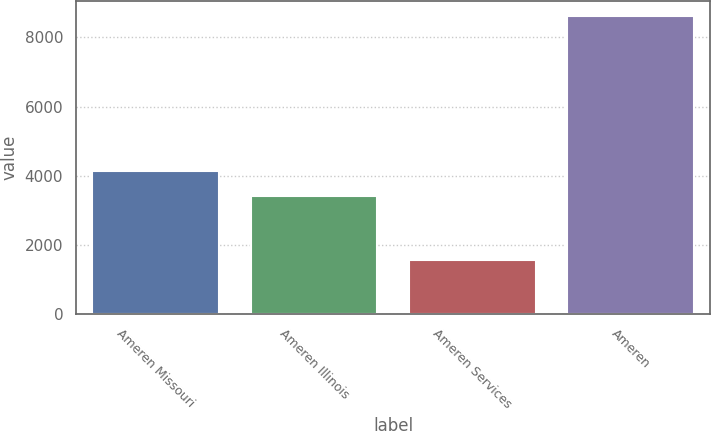Convert chart to OTSL. <chart><loc_0><loc_0><loc_500><loc_500><bar_chart><fcel>Ameren Missouri<fcel>Ameren Illinois<fcel>Ameren Services<fcel>Ameren<nl><fcel>4129.2<fcel>3423<fcel>1553<fcel>8615<nl></chart> 